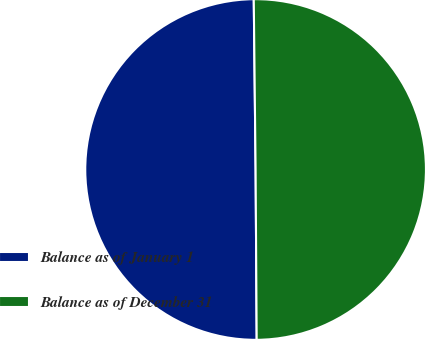Convert chart. <chart><loc_0><loc_0><loc_500><loc_500><pie_chart><fcel>Balance as of January 1<fcel>Balance as of December 31<nl><fcel>49.93%<fcel>50.07%<nl></chart> 